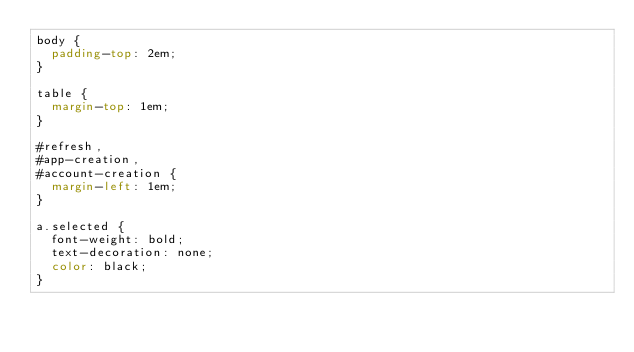Convert code to text. <code><loc_0><loc_0><loc_500><loc_500><_CSS_>body {
  padding-top: 2em;
}

table {
  margin-top: 1em;
}

#refresh,
#app-creation,
#account-creation {
  margin-left: 1em;
}

a.selected {
  font-weight: bold;
  text-decoration: none;
  color: black;
}
</code> 